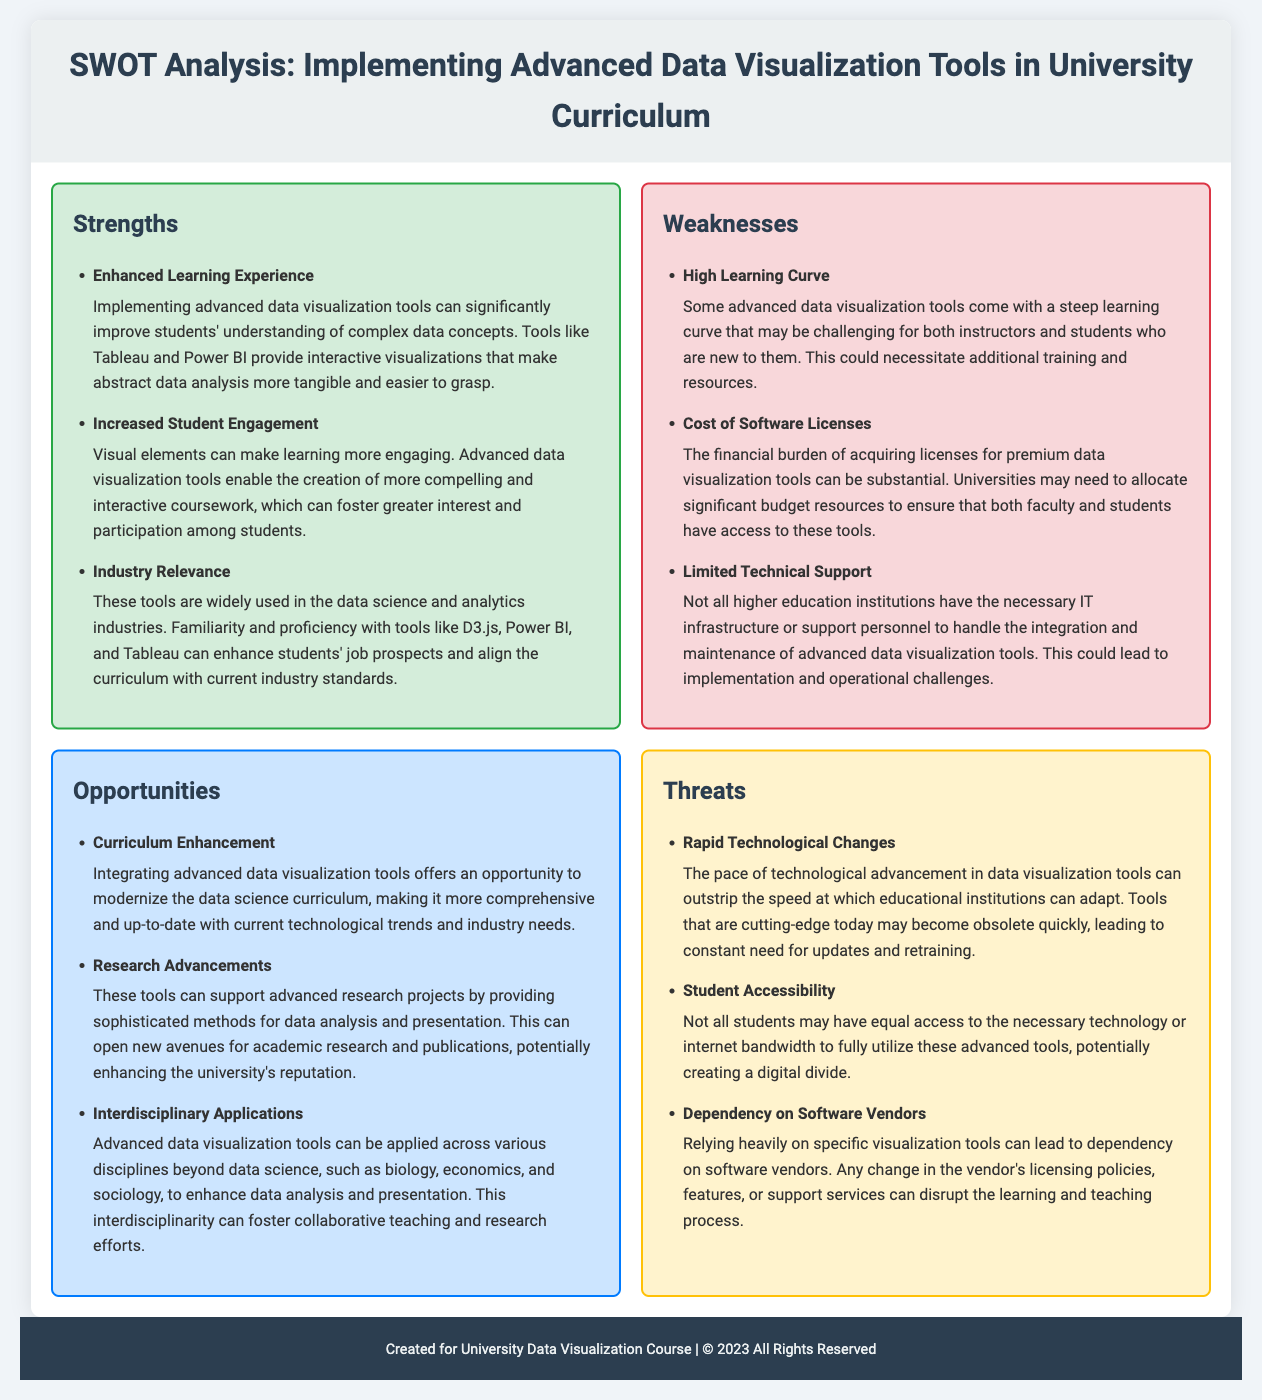What is one strength of implementing advanced data visualization tools? The document lists several strengths, one of which is that these tools can significantly improve students' understanding of complex data concepts.
Answer: Enhanced Learning Experience What is a weakness related to the cost of implementing these tools? The document mentions that acquiring licenses for premium tools can be a financial burden, therefore highlighting financial constraints as a significant weakness.
Answer: Cost of Software Licenses What opportunity could arise from integrating these tools into the curriculum? The document discusses multiple opportunities, including the chance to modernize the curriculum with current technological trends.
Answer: Curriculum Enhancement Name one threat associated with the rapid development of technology. The document points out that technological advancements can outpace the ability of educational institutions to adapt, leading to obsolescence.
Answer: Rapid Technological Changes What is a potential issue that might affect student accessibility? According to the document, not all students may have equal access to technology or internet bandwidth, which speaks to potential accessibility issues.
Answer: Student Accessibility How many strengths are listed in the document? The document includes three specific strengths listed under the strengths section.
Answer: Three What can be a benefit of advanced data visualization tools in research? The document states that these tools can support advanced research projects, opening new avenues for academic investigations.
Answer: Research Advancements Which specific section addresses 'Limited Technical Support'? The mention of limited support is found under the weaknesses section of the document.
Answer: Weaknesses What aspect of the curriculum does the document suggest can be enhanced? The document indicates that integrating advanced data visualization tools can modernize and update various educational curriculums.
Answer: Curriculum Enhancement 